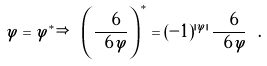Convert formula to latex. <formula><loc_0><loc_0><loc_500><loc_500>\varphi = \varphi ^ { * } \Rightarrow \ \left ( \frac { \ 6 } { \ 6 \varphi } \right ) ^ { * } = ( - 1 ) ^ { | \varphi | } \, \frac { \ 6 } { \ 6 \varphi } \ .</formula> 